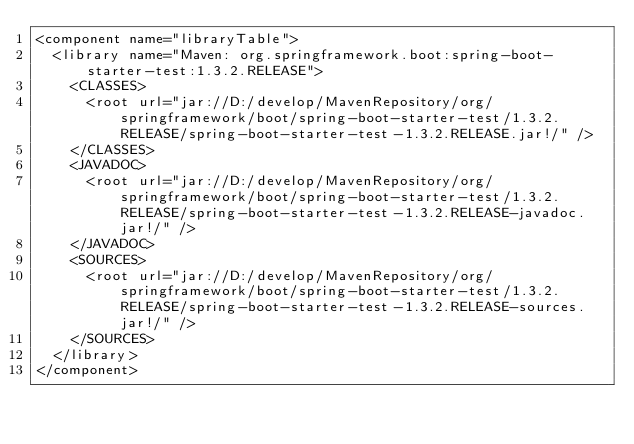Convert code to text. <code><loc_0><loc_0><loc_500><loc_500><_XML_><component name="libraryTable">
  <library name="Maven: org.springframework.boot:spring-boot-starter-test:1.3.2.RELEASE">
    <CLASSES>
      <root url="jar://D:/develop/MavenRepository/org/springframework/boot/spring-boot-starter-test/1.3.2.RELEASE/spring-boot-starter-test-1.3.2.RELEASE.jar!/" />
    </CLASSES>
    <JAVADOC>
      <root url="jar://D:/develop/MavenRepository/org/springframework/boot/spring-boot-starter-test/1.3.2.RELEASE/spring-boot-starter-test-1.3.2.RELEASE-javadoc.jar!/" />
    </JAVADOC>
    <SOURCES>
      <root url="jar://D:/develop/MavenRepository/org/springframework/boot/spring-boot-starter-test/1.3.2.RELEASE/spring-boot-starter-test-1.3.2.RELEASE-sources.jar!/" />
    </SOURCES>
  </library>
</component></code> 